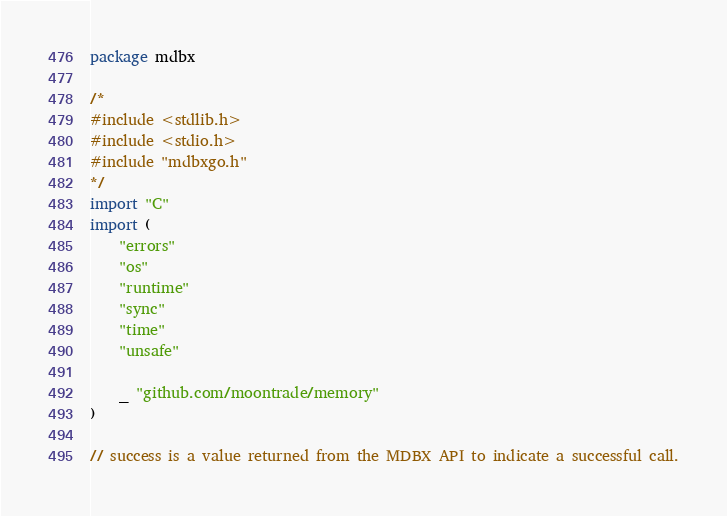Convert code to text. <code><loc_0><loc_0><loc_500><loc_500><_Go_>package mdbx

/*
#include <stdlib.h>
#include <stdio.h>
#include "mdbxgo.h"
*/
import "C"
import (
	"errors"
	"os"
	"runtime"
	"sync"
	"time"
	"unsafe"

	_ "github.com/moontrade/memory"
)

// success is a value returned from the MDBX API to indicate a successful call.</code> 